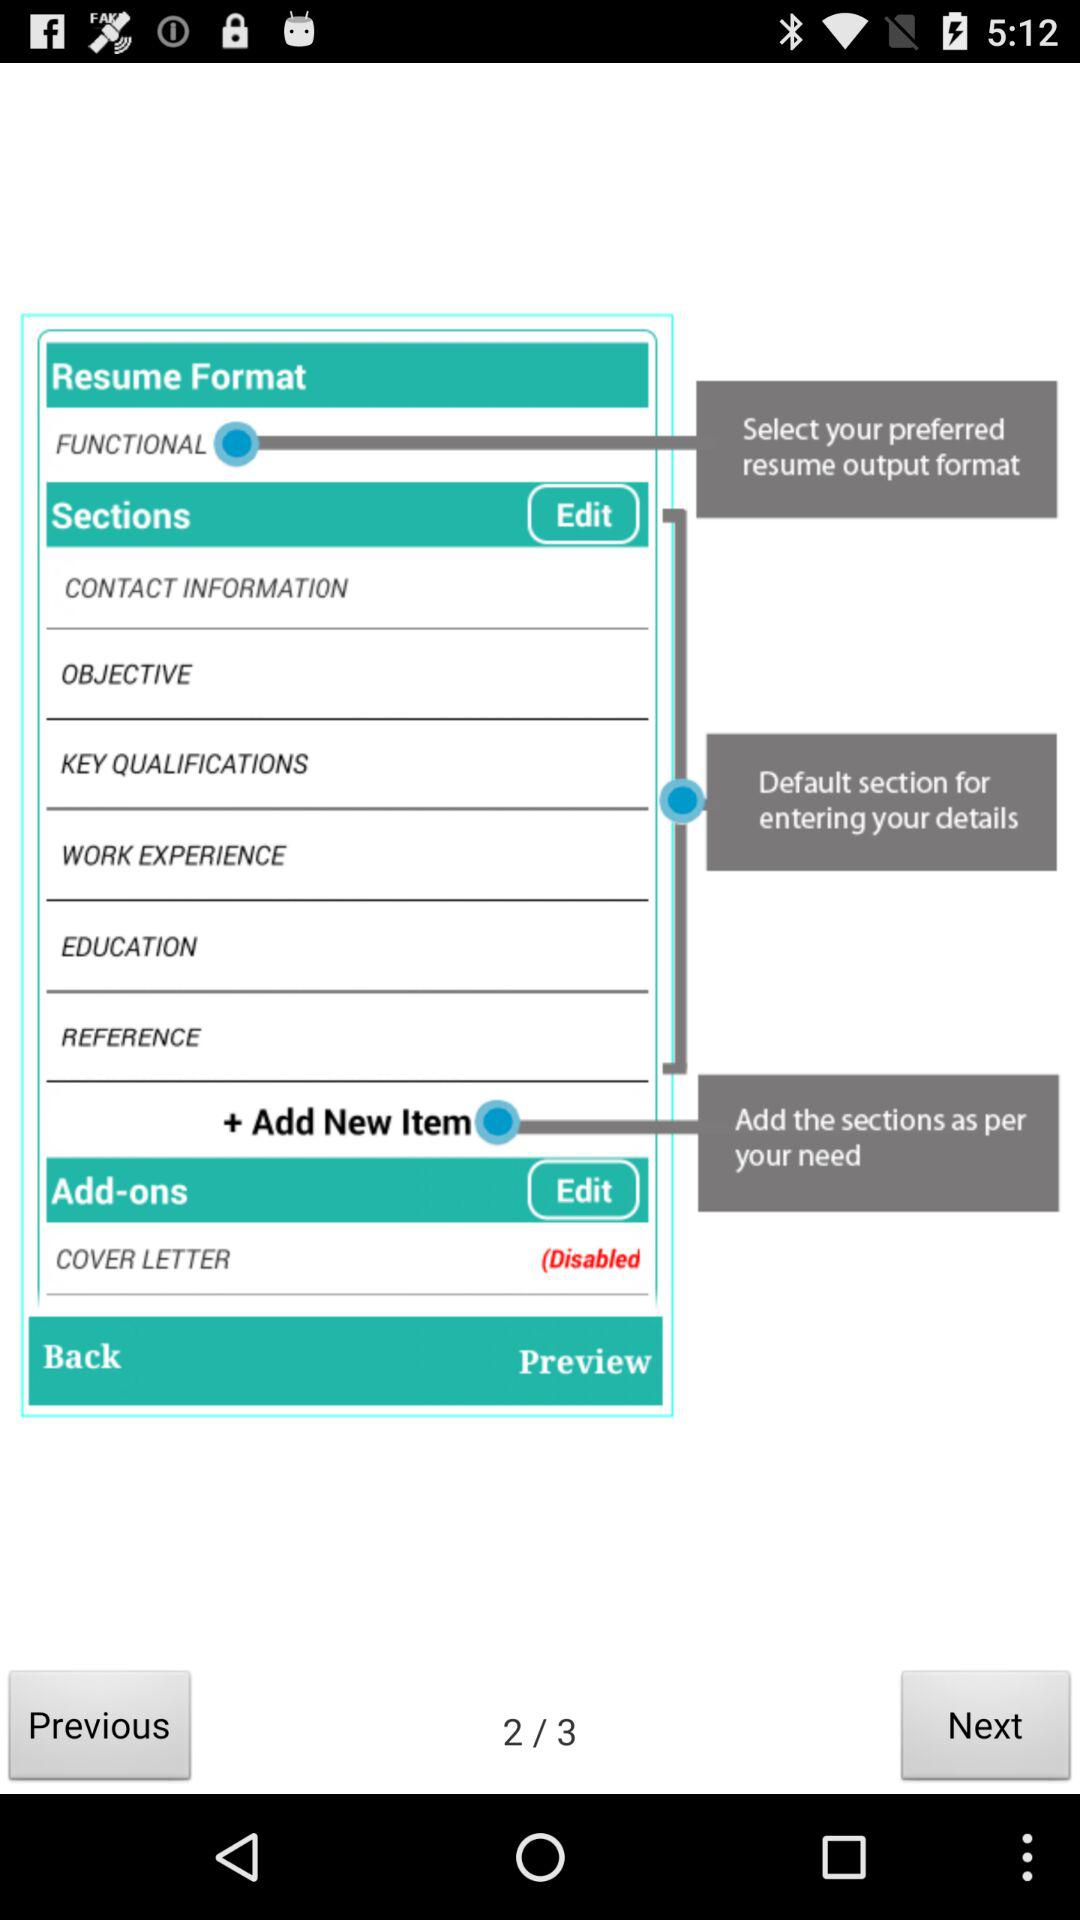Which page number am I on? You are on page number 2. 